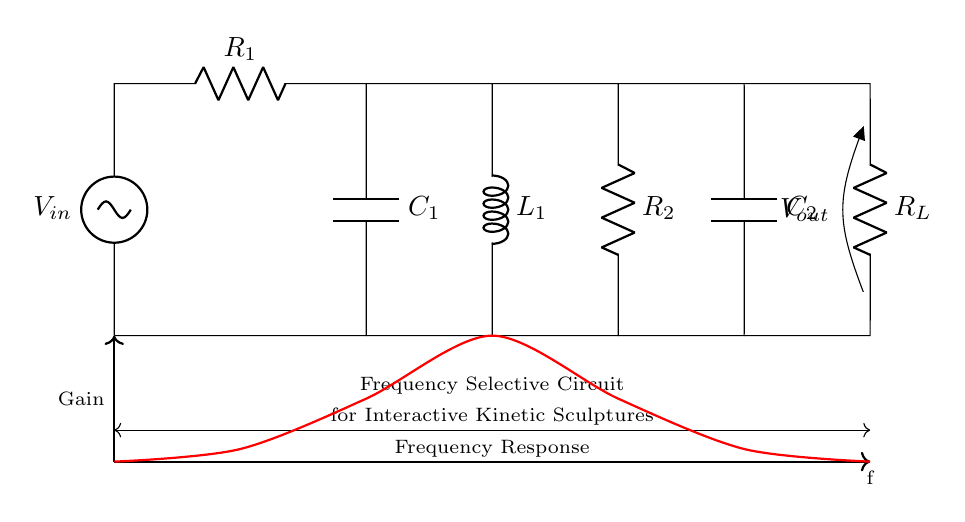What is the input voltage of the circuit? The input voltage is labeled as V in the circuit diagram, representing the potential difference applied at the circuit's entry point.
Answer: V in What type of components are used in this circuit? This circuit consists of resistors, capacitors, an inductor, and a voltage source, as can be identified by their standard symbols in the diagram.
Answer: Resistor, Capacitor, Inductor What is the role of C1 in the circuit? C1 acts as a capacitor which helps in filtering specific frequency components of the input signal, affecting the transient response and the frequency response of the circuit.
Answer: Frequency filtering What is the total number of resistors in this circuit? There are three resistors identified in the circuit diagram: R1, R2, and R_L, contributing to different stages of the filtering process.
Answer: 3 What can be inferred about the function of L1 in the circuit? L1, as an inductor, functions to store energy in the magnetic field and is crucial in influencing the circuit's frequency response by allowing only certain frequencies to pass through.
Answer: Energy storage What is the output voltage location labeled as? The output voltage is labeled as V out in the diagram, indicating where the filtered signal is taken from the circuit after processing the input signal.
Answer: V out At what point does the circuit exhibit minimum gain? The circuit exhibits minimum gain, as indicated by the plot in the diagram, specifically around points where the frequency response curve dips, suggesting lower signal amplification at those frequencies.
Answer: Around six 